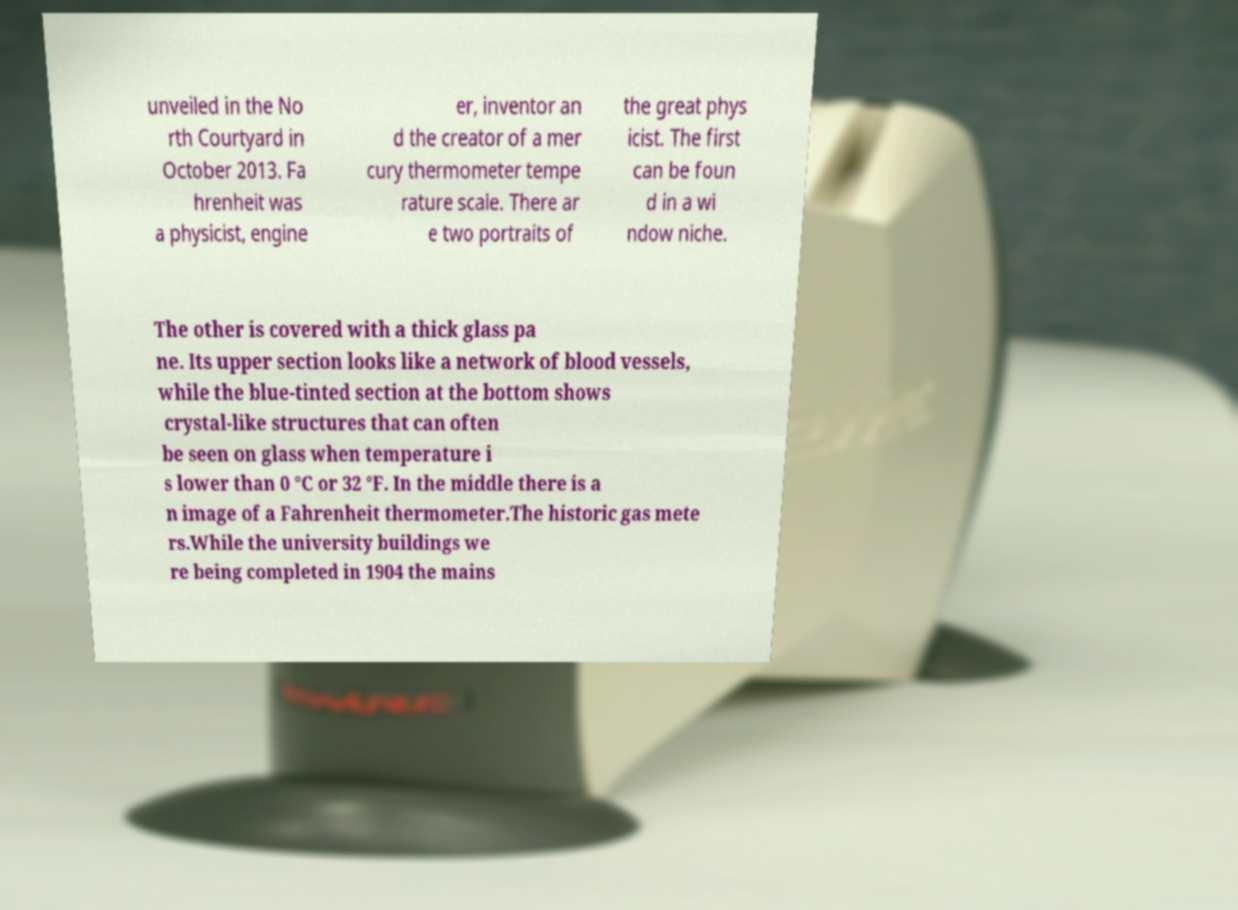There's text embedded in this image that I need extracted. Can you transcribe it verbatim? unveiled in the No rth Courtyard in October 2013. Fa hrenheit was a physicist, engine er, inventor an d the creator of a mer cury thermometer tempe rature scale. There ar e two portraits of the great phys icist. The first can be foun d in a wi ndow niche. The other is covered with a thick glass pa ne. Its upper section looks like a network of blood vessels, while the blue-tinted section at the bottom shows crystal-like structures that can often be seen on glass when temperature i s lower than 0 °C or 32 °F. In the middle there is a n image of a Fahrenheit thermometer.The historic gas mete rs.While the university buildings we re being completed in 1904 the mains 